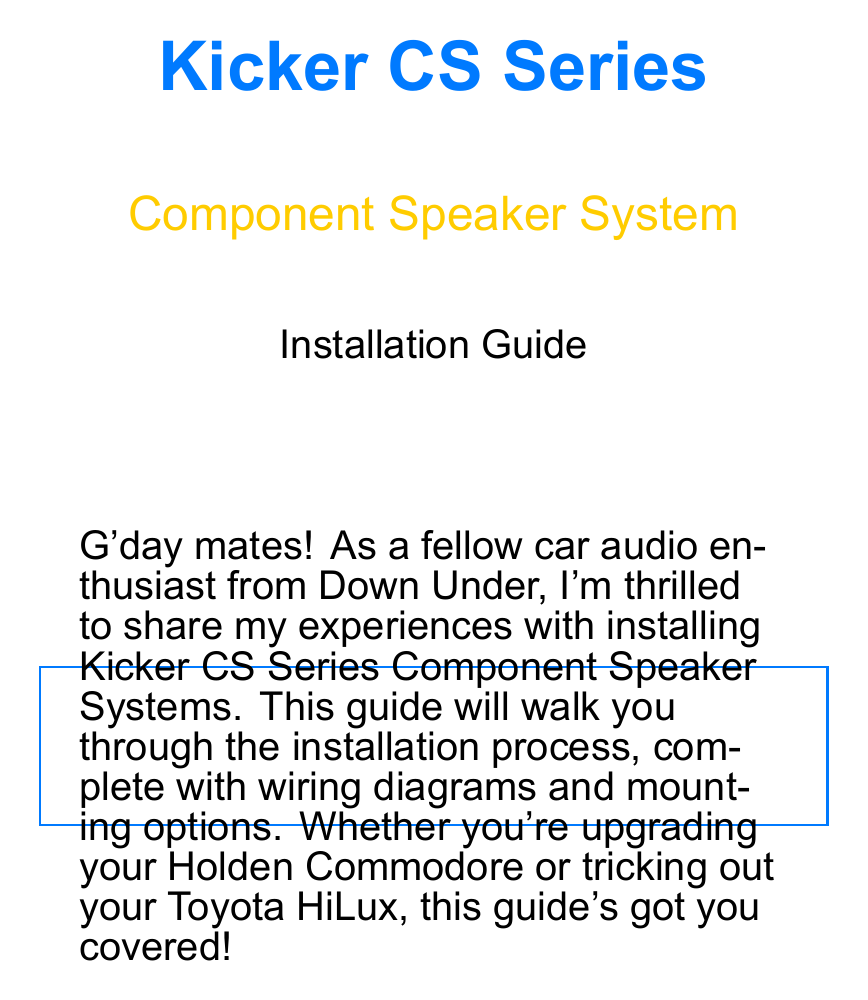What items are included in the package? The package contents are listed specifically in the document.
Answer: 2 Kicker CS Series woofers, 2 Kicker CS Series tweeters, 2 Kicker CS Series crossovers, Mounting hardware, Speaker wire, Owner's manual What tools are required for installation? The tools required are explicitly mentioned in the section on tools.
Answer: Wire strippers, Crimping tool, Screwdriver set, Drill with various bits, Panel removal tools, Multimeter What is the positive wire color in the wiring diagram? The wire colors are detailed in the wiring diagram section.
Answer: Red What is the first step in the installation process? The installation steps are outlined in a numbered format.
Answer: Prepare the vehicle Where should the crossovers be mounted? The description in the installation steps suggests a preferred mounting location.
Answer: Behind the kick panels What should you do if there's no sound from one speaker? The troubleshooting section provides direct solutions to problems.
Answer: Check wiring connections What modification did the author make for the tweeters? The mounting options section describes specific adjustments made by the author.
Answer: Custom A-pillar pods using fiberglass Which head unit is recommended for better source quality? The tips and tricks section offers recommendations regarding equipment.
Answer: Pioneer DEH-80PRS 